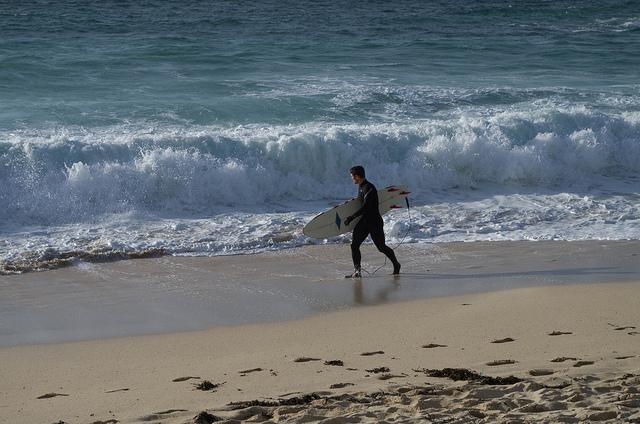What is the man wearing?
Write a very short answer. Wetsuit. What gender is the rider?
Quick response, please. Male. What is the man carrying?
Keep it brief. Surfboard. Could this be sunset?
Concise answer only. No. What is the beach made of?
Short answer required. Sand. How tall is the wave?
Be succinct. 3 feet. 